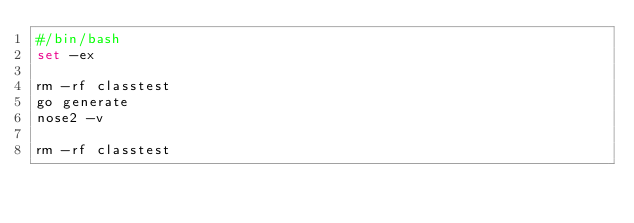<code> <loc_0><loc_0><loc_500><loc_500><_Bash_>#/bin/bash
set -ex

rm -rf classtest
go generate
nose2 -v

rm -rf classtest
</code> 